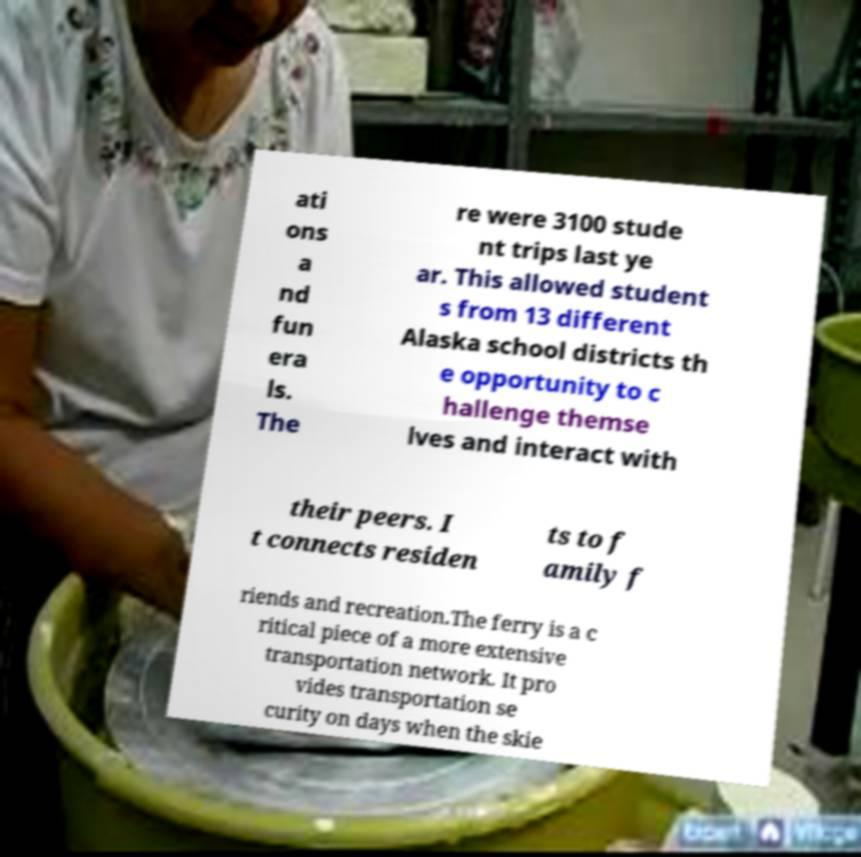Could you assist in decoding the text presented in this image and type it out clearly? ati ons a nd fun era ls. The re were 3100 stude nt trips last ye ar. This allowed student s from 13 different Alaska school districts th e opportunity to c hallenge themse lves and interact with their peers. I t connects residen ts to f amily f riends and recreation.The ferry is a c ritical piece of a more extensive transportation network. It pro vides transportation se curity on days when the skie 